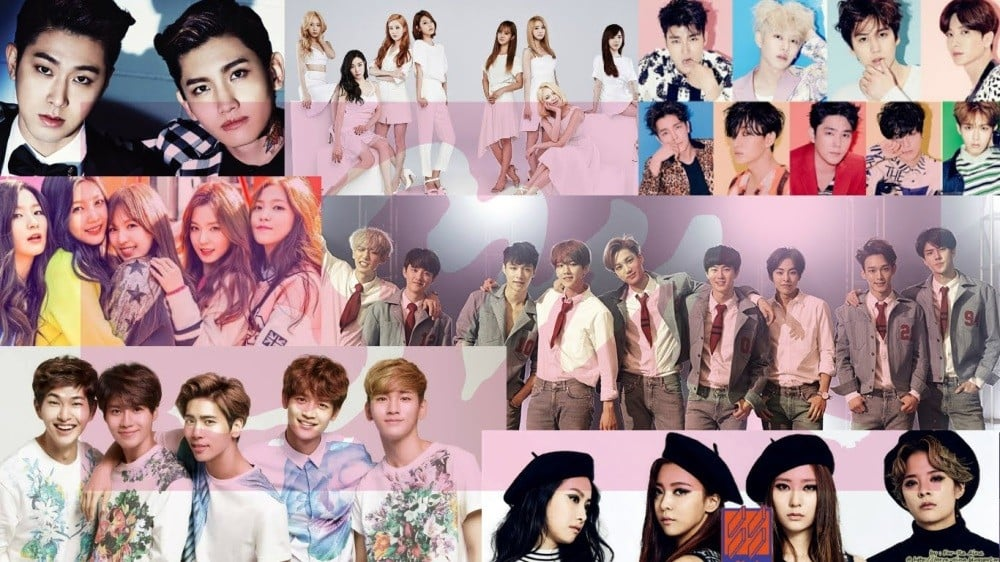How does the fashion and styling of the groups reflect the trends in pop culture during the time the photograph was taken? The fashion and styling displayed by the groups in the photograph reflect a meticulous and vibrant image often associated with K-pop idols. Their coordinated outfits signify a strong group identity designed to appeal to their fanbase while aiming to capture attention in the competitive entertainment industry. The use of bold colors, unique accessories, and varied textures in their clothing are quintessential elements of K-pop fashion, meant to create a distinct and memorable visual impact. The diverse range of hairstyles and makeup—ranging from natural looks to avant-garde styles—illustrate a fusion of contemporary fashion with pop culture elements, marking a trend-setting approach typical of K-pop groups. The confident poses and expressions further convey a sense of charisma and stage presence, crucial for performance-oriented K-pop groups. Together, these elements encapsulate the dynamic and highly visual nature of pop culture trends during the era in which the photograph was taken. 